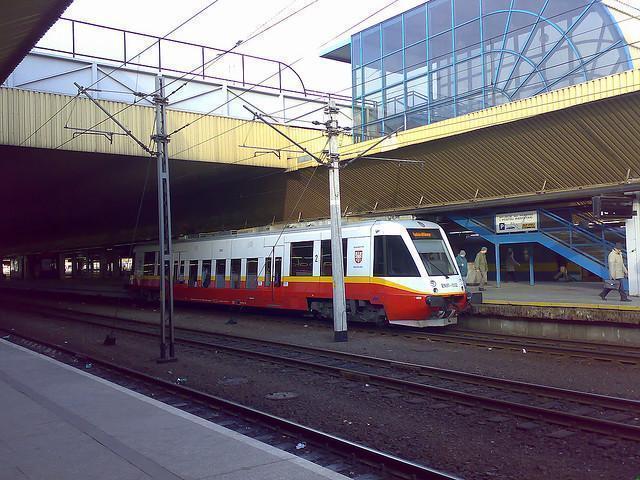What are the wires above the train used for?
Indicate the correct response and explain using: 'Answer: answer
Rationale: rationale.'
Options: Climbing, hanging, decoration, power. Answer: power.
Rationale: The wires are for power. 